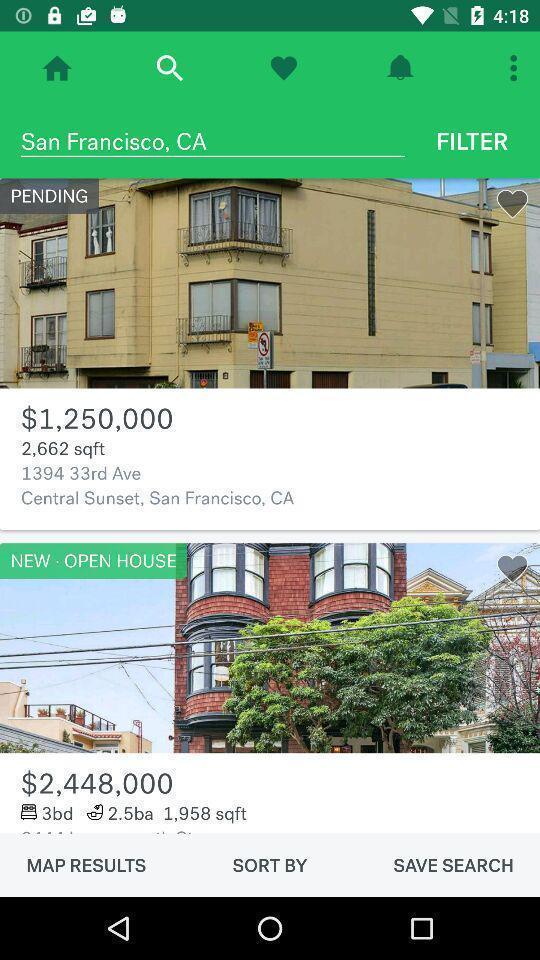Summarize the information in this screenshot. Search page of homes. 